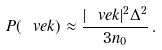Convert formula to latex. <formula><loc_0><loc_0><loc_500><loc_500>P ( \ v e k ) \approx \frac { | \ v e k | ^ { 2 } \Delta ^ { 2 } } { 3 n _ { 0 } } \, .</formula> 